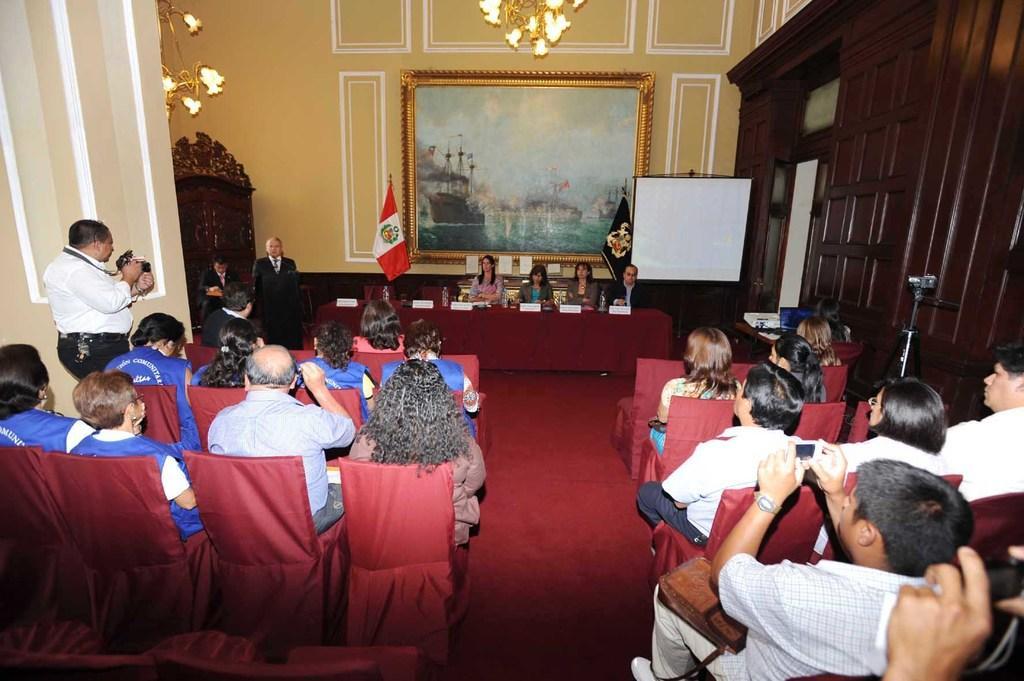How would you summarize this image in a sentence or two? In this image in the center there are group of persons sitting on a chair and there are persons on the left side standing. In the background there is a frame on the wall and there are flags, there is a white board. On the right side there are cupboards and in the front there are empty chairs. On the right side there is a man sitting and holding a mobile phone and clicking a photo. On the left side there is a man standing and holding a camera and on the top there are chandeliers hanging. 